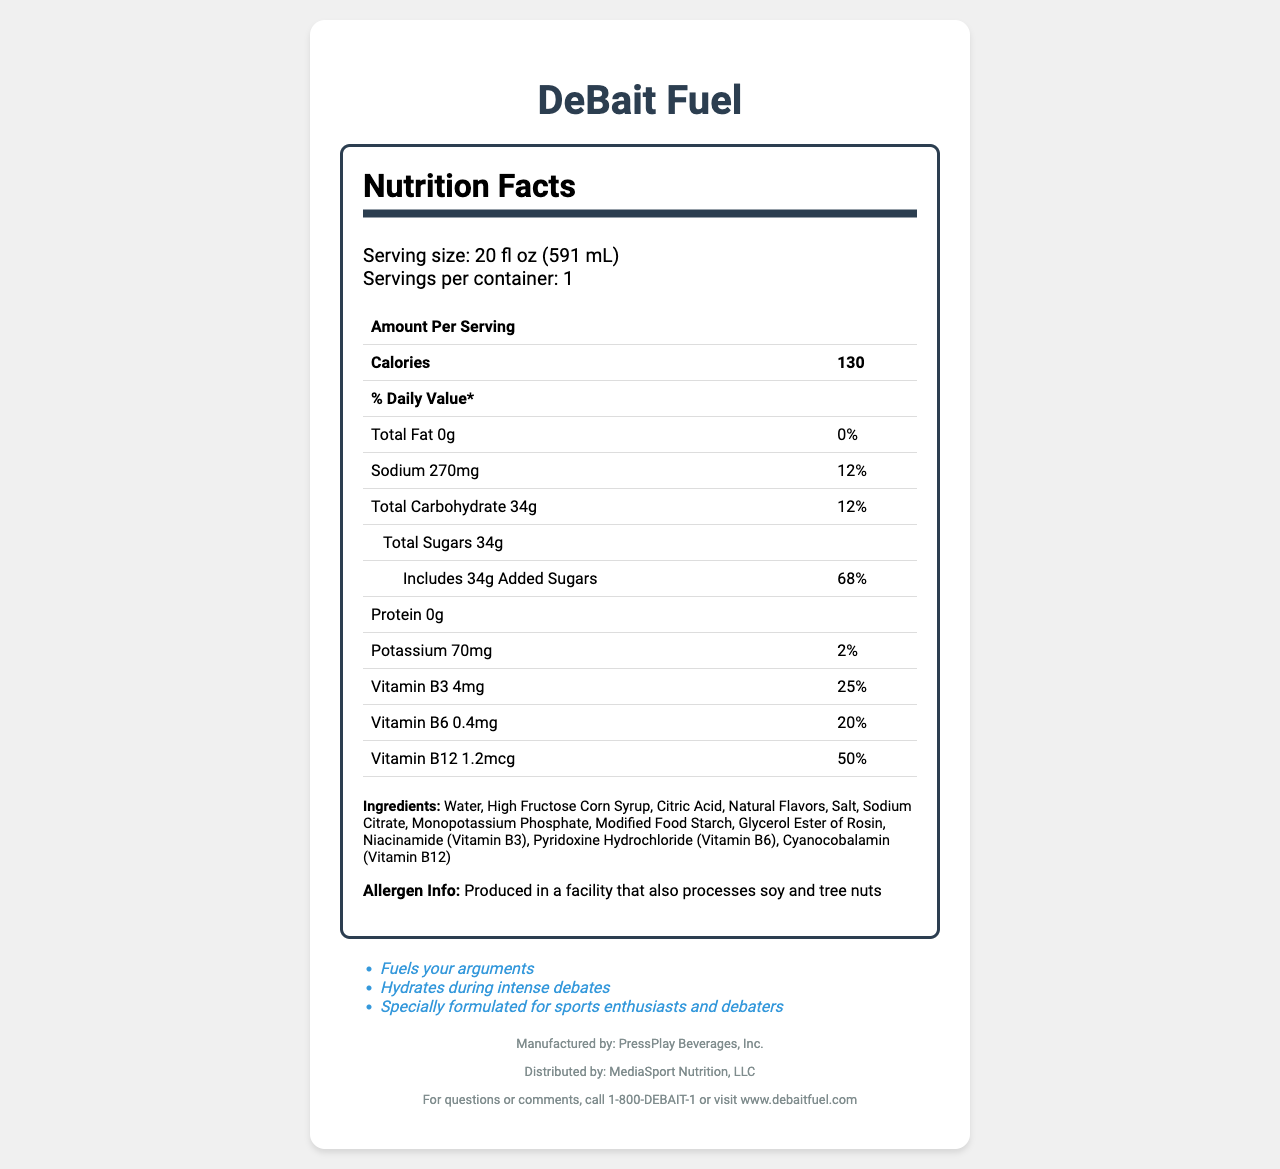what is the serving size? The serving size is listed at the beginning of the "Nutrition Facts" section of the document.
Answer: 20 fl oz (591 mL) how many calories are in one serving of DeBait Fuel? The number of calories per serving is prominently displayed in the "Nutrition Facts" section.
Answer: 130 what percentage of the daily value of sodium does one serving contain? The daily value percentage for sodium is provided right next to its amount in milligrams (270mg).
Answer: 12% how much protein is in DeBait Fuel? The protein content is listed as 0g in the "Nutrition Facts" section.
Answer: 0g what vitamin has the highest daily value percentage in the drink? The vitamin with the highest daily value percentage is Vitamin B12 at 50%.
Answer: Vitamin B12 what is the main ingredient in DeBait Fuel? The first ingredient listed, which usually represents the highest quantity, is water.
Answer: Water which company manufactures DeBait Fuel? The manufacturer is listed in the contact information section at the end of the document.
Answer: PressPlay Beverages, Inc. how many grams of added sugars are in one serving? A. 20g B. 30g C. 34g D. 40g The document indicates that one serving includes 34g of added sugars.
Answer: C. 34g what are some of the sports drink's marketing claims? A. Increases stamina B. Fuels your arguments C. Best taste D. Refreshes instantly Among the claims listed in the document, "Fuels your arguments" is mentioned.
Answer: B. Fuels your arguments does DeBait Fuel contain any allergens? The drink is produced in a facility that also processes soy and tree nuts, which are common allergens.
Answer: Yes describe the main purpose of the document. The document not only lists detailed nutrition facts but also includes ingredients, allergen information, marketing claims, and contact information for the manufacturer and distributor.
Answer: The main purpose of the document is to provide nutritional information, including ingredient details, allergen info, and marketing claims for DeBait Fuel, a popular sports drink consumed during debates. what is the serving size in milliliters? The serving size is listed as 591 mL, converting from 20 fl oz.
Answer: 591 mL how much potassium does the sports drink provide? The amount of potassium is listed as 70mg in the "Nutrition Facts" section.
Answer: 70mg which company distributes DeBait Fuel? A. MediaSport Nutrition, LLC B. PressPlay Beverages, Inc C. SportsFuel Ltd. D. Debate Drink Co. The distributor is mentioned at the end of the document as MediaSport Nutrition, LLC.
Answer: A. MediaSport Nutrition, LLC is there any information about fiber content? The document does not mention fiber content in the "Nutrition Facts" section.
Answer: No what is the first marketing claim listed for DeBait Fuel? The first marketing claim listed is "Fuels your arguments".
Answer: Fuels your arguments 